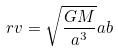Convert formula to latex. <formula><loc_0><loc_0><loc_500><loc_500>r v = \sqrt { \frac { G M } { a ^ { 3 } } } a b</formula> 